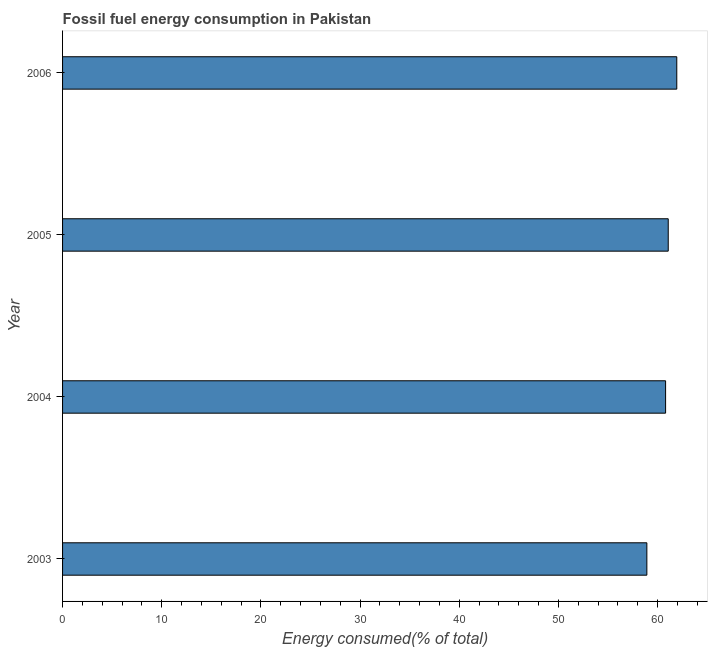Does the graph contain any zero values?
Your answer should be compact. No. What is the title of the graph?
Offer a terse response. Fossil fuel energy consumption in Pakistan. What is the label or title of the X-axis?
Provide a short and direct response. Energy consumed(% of total). What is the label or title of the Y-axis?
Provide a short and direct response. Year. What is the fossil fuel energy consumption in 2003?
Make the answer very short. 58.93. Across all years, what is the maximum fossil fuel energy consumption?
Your answer should be compact. 61.94. Across all years, what is the minimum fossil fuel energy consumption?
Offer a terse response. 58.93. In which year was the fossil fuel energy consumption maximum?
Make the answer very short. 2006. In which year was the fossil fuel energy consumption minimum?
Ensure brevity in your answer.  2003. What is the sum of the fossil fuel energy consumption?
Offer a terse response. 242.76. What is the difference between the fossil fuel energy consumption in 2003 and 2004?
Give a very brief answer. -1.89. What is the average fossil fuel energy consumption per year?
Keep it short and to the point. 60.69. What is the median fossil fuel energy consumption?
Ensure brevity in your answer.  60.95. What is the ratio of the fossil fuel energy consumption in 2004 to that in 2005?
Make the answer very short. 1. Is the fossil fuel energy consumption in 2004 less than that in 2006?
Ensure brevity in your answer.  Yes. What is the difference between the highest and the second highest fossil fuel energy consumption?
Your answer should be very brief. 0.86. Is the sum of the fossil fuel energy consumption in 2003 and 2004 greater than the maximum fossil fuel energy consumption across all years?
Keep it short and to the point. Yes. What is the difference between the highest and the lowest fossil fuel energy consumption?
Make the answer very short. 3.02. How many bars are there?
Make the answer very short. 4. Are all the bars in the graph horizontal?
Your answer should be very brief. Yes. What is the difference between two consecutive major ticks on the X-axis?
Your response must be concise. 10. Are the values on the major ticks of X-axis written in scientific E-notation?
Your answer should be compact. No. What is the Energy consumed(% of total) in 2003?
Provide a short and direct response. 58.93. What is the Energy consumed(% of total) in 2004?
Make the answer very short. 60.81. What is the Energy consumed(% of total) in 2005?
Provide a short and direct response. 61.08. What is the Energy consumed(% of total) of 2006?
Give a very brief answer. 61.94. What is the difference between the Energy consumed(% of total) in 2003 and 2004?
Provide a succinct answer. -1.89. What is the difference between the Energy consumed(% of total) in 2003 and 2005?
Provide a succinct answer. -2.15. What is the difference between the Energy consumed(% of total) in 2003 and 2006?
Provide a succinct answer. -3.02. What is the difference between the Energy consumed(% of total) in 2004 and 2005?
Ensure brevity in your answer.  -0.27. What is the difference between the Energy consumed(% of total) in 2004 and 2006?
Provide a short and direct response. -1.13. What is the difference between the Energy consumed(% of total) in 2005 and 2006?
Provide a short and direct response. -0.86. What is the ratio of the Energy consumed(% of total) in 2003 to that in 2004?
Provide a succinct answer. 0.97. What is the ratio of the Energy consumed(% of total) in 2003 to that in 2006?
Your answer should be compact. 0.95. What is the ratio of the Energy consumed(% of total) in 2004 to that in 2006?
Your response must be concise. 0.98. What is the ratio of the Energy consumed(% of total) in 2005 to that in 2006?
Your response must be concise. 0.99. 